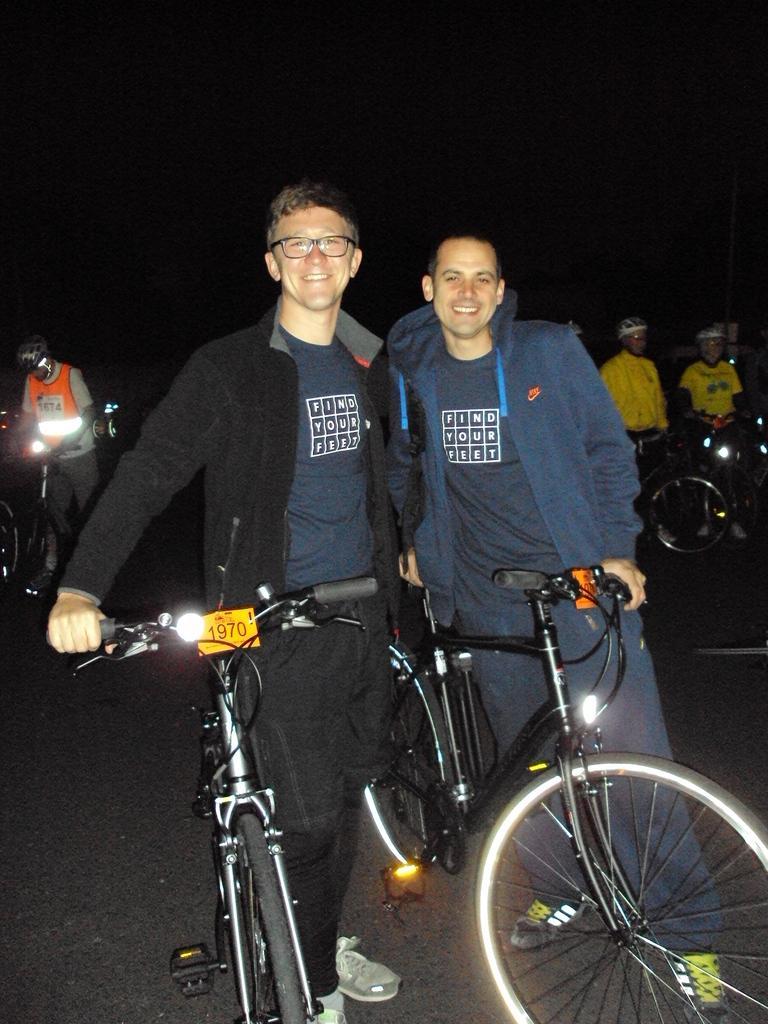Please provide a concise description of this image. In this picture we can see two men wore jacket holding bicycles on road and in background we can see three persons holding bicycles and it is dark. 